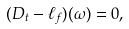Convert formula to latex. <formula><loc_0><loc_0><loc_500><loc_500>( D _ { t } - \ell _ { f } ) ( \omega ) = 0 ,</formula> 